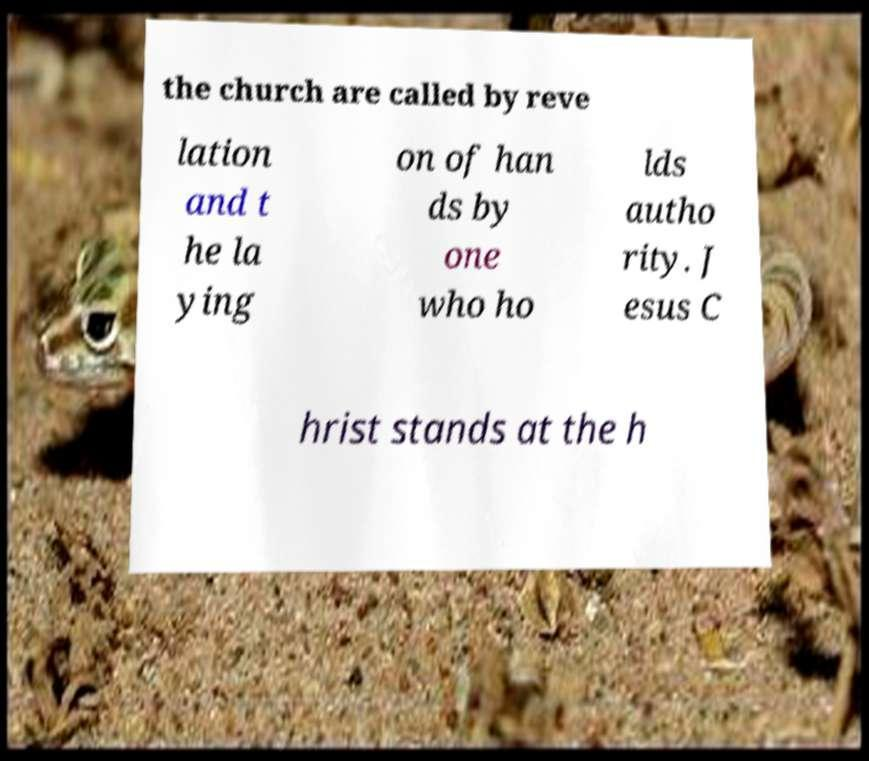Can you read and provide the text displayed in the image?This photo seems to have some interesting text. Can you extract and type it out for me? the church are called by reve lation and t he la ying on of han ds by one who ho lds autho rity. J esus C hrist stands at the h 